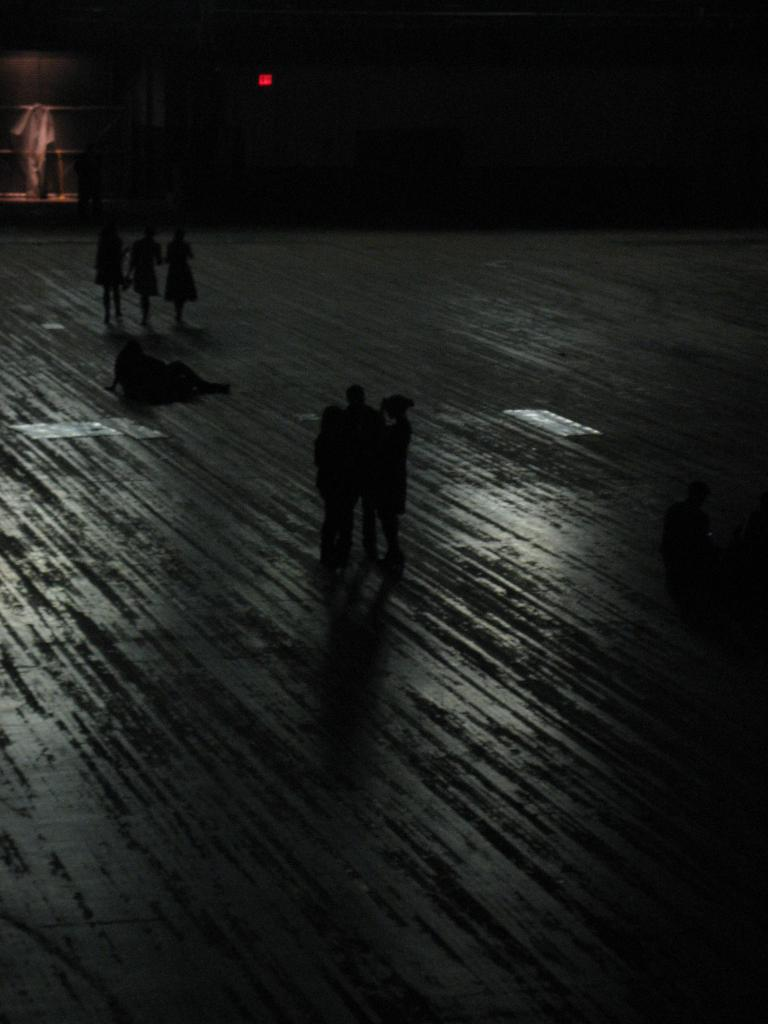Who or what is present in the image? There are people in the image. What can be seen in the background of the image? There is a wall in the background of the image. Can you describe any other elements in the image? There is a light visible in the image. What type of cap is the horse wearing in the image? There is no horse present in the image, and therefore no cap for a horse to wear. 